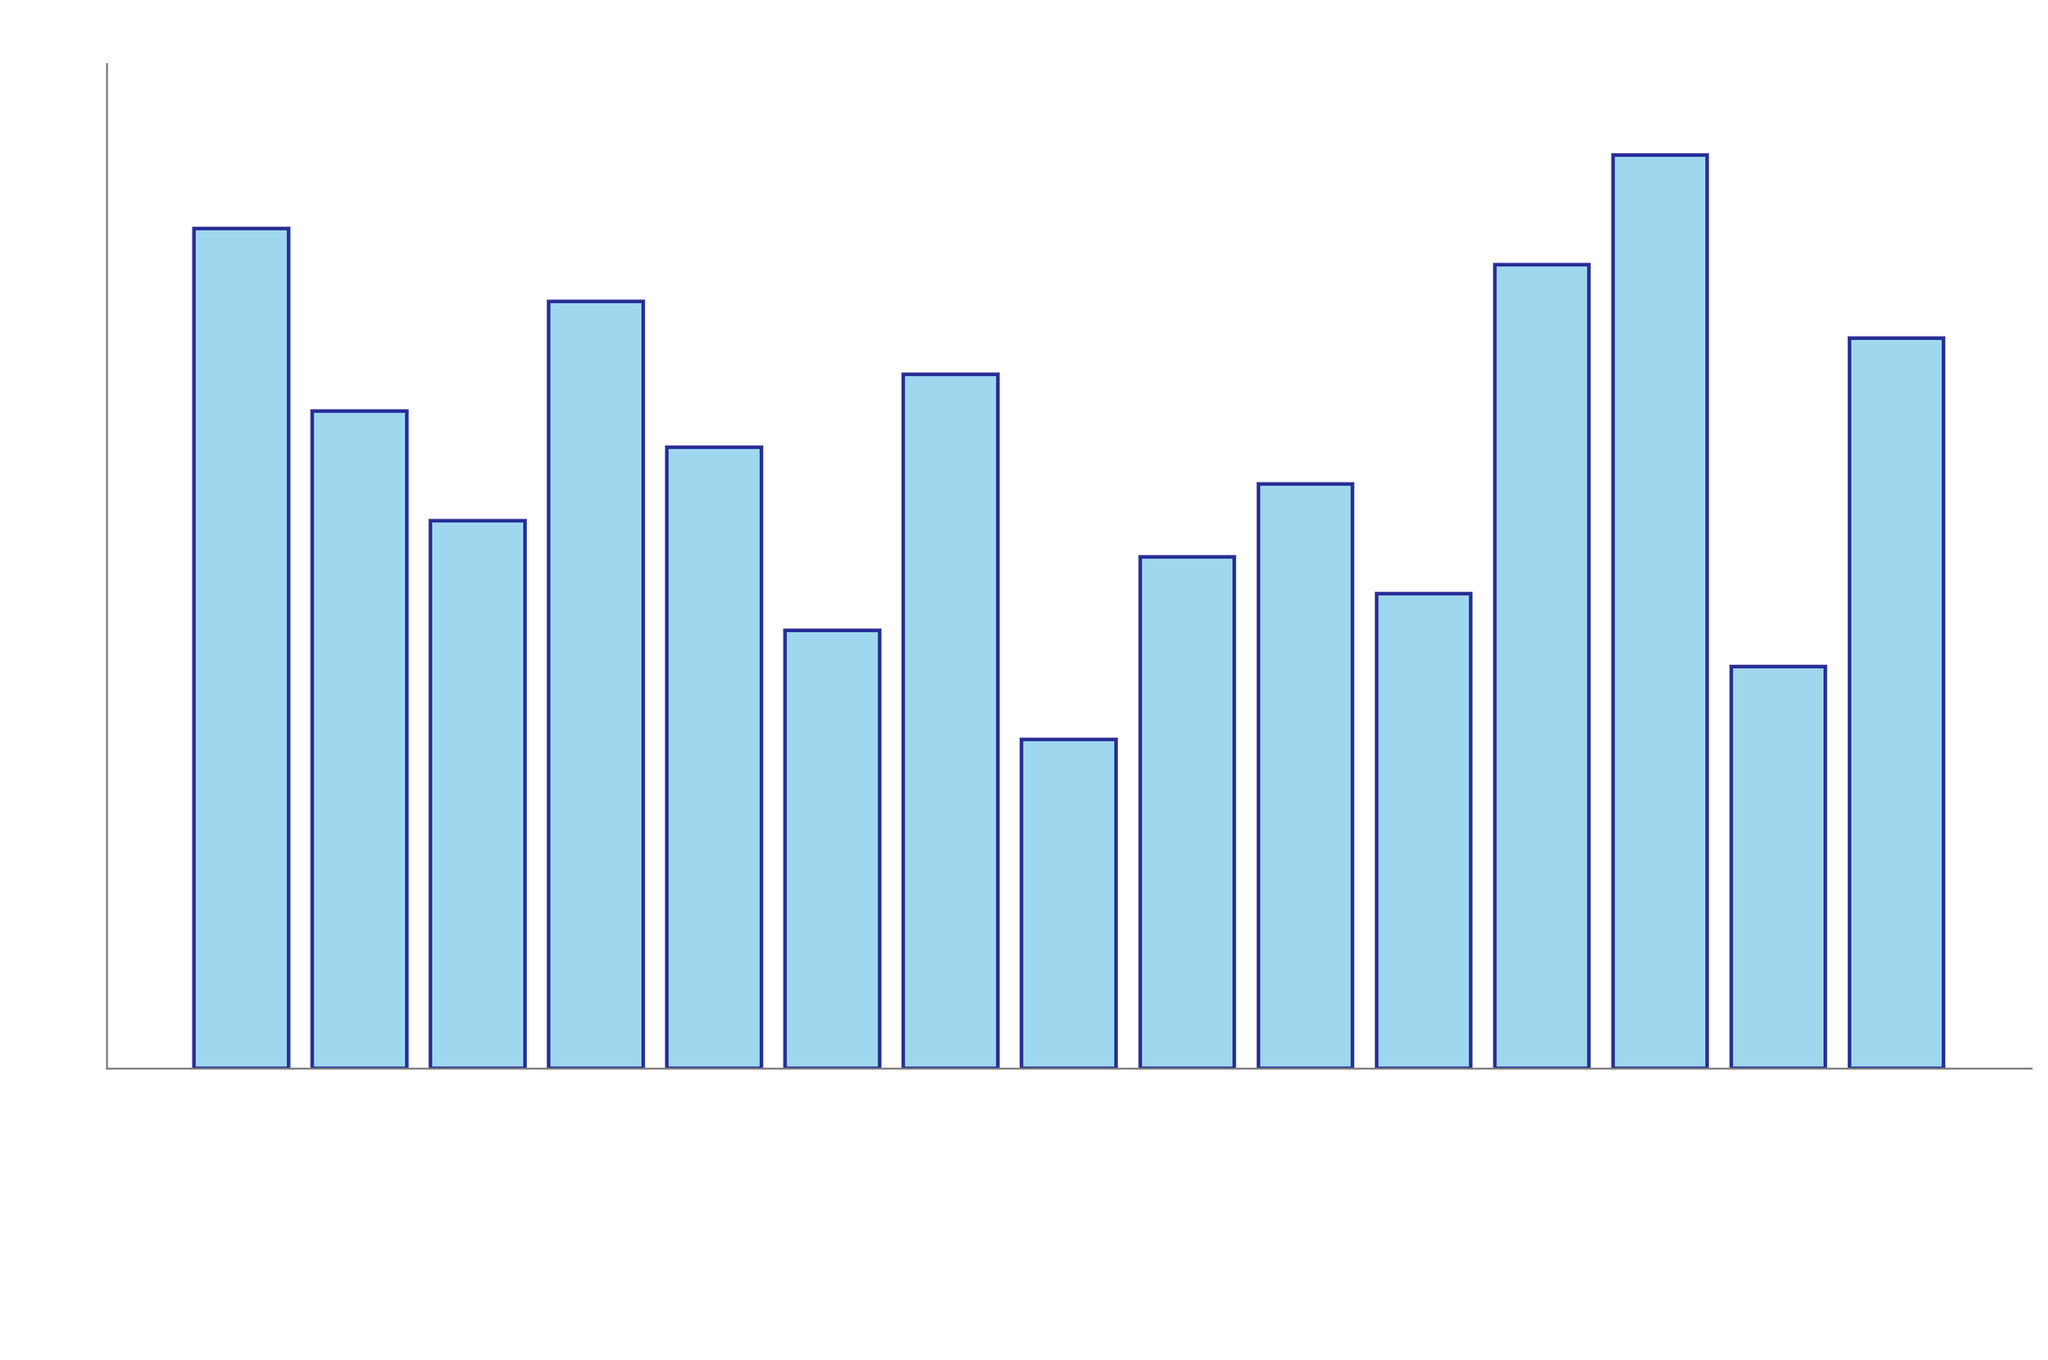Which technique has the highest productivity gain? The bar representing Deep Work Sessions is the tallest, indicating the highest productivity gain percentage.
Answer: Deep Work Sessions Which technique has a productivity gain of 18%? The Time Blocking bar is at the height indicating a productivity gain of 18%.
Answer: Time Blocking How much higher is the productivity gain of Deep Work Sessions compared to Bullet Journaling? Deep Work Sessions has a productivity gain of 25% and Bullet Journaling has a gain of 12%, so the difference is 25% - 12% = 13%.
Answer: 13% Which techniques have a productivity gain higher than 20%? Techniques with productivity gains higher than 20% are those with bars taller than the 20% mark. These are Pomodoro Technique (23%), Kanban Boards (21%), Pareto Principle (80/20 Rule) (22%), and Deep Work Sessions (25%).
Answer: Pomodoro Technique, Kanban Boards, Pareto Principle (80/20 Rule), Deep Work Sessions What is the total productivity gain of Pomodoro Technique, Time Blocking, and Eisenhower Matrix combined? Sum the productivity gains: Pomodoro Technique (23%) + Time Blocking (18%) + Eisenhower Matrix (15%) = 23% + 18% + 15% = 56%.
Answer: 56% Which techniques have an equal productivity gain? Techniques with the same bar heights indicating equal productivity gains are Time Blocking and Getting Things Done (GTD), both at 18%.
Answer: Time Blocking, Getting Things Done (GTD) What is the median productivity gain of all the techniques? List the productivity gains in ascending order: 9%, 11%, 12%, 13%, 14%, 15%, 16%, 17%, 18%, 18%, 19%, 20%, 21%, 22%, 23%, 25%. The median is the middle value, which is the 8th value in the sorted list, i.e., 17%.
Answer: 17% Compare the productivity gains of Eat That Frog and Task Batching. Which is higher? The bar for Task Batching is higher than that for Eat That Frog, indicating a higher productivity gain for Task Batching (20%) compared to Eat That Frog (16%).
Answer: Task Batching What is the visual difference between the bars for the Two-Minute Rule and Pomodoro Technique? The bar for the Pomodoro Technique is visually taller than that for the Two-Minute Rule, indicating a higher productivity gain for the Pomodoro Technique (23%) compared to the Two-Minute Rule (9%).
Answer: Pomodoro Technique is taller What is the average productivity gain of the techniques with more than 15% gain? List the productivity gains: Pomodoro Technique (23%), Time Blocking (18%), Kanban Boards (21%), Getting Things Done (GTD) (17%), Timeboxing (19%), Pareto Principle (80/20 Rule) (22%), Deep Work Sessions (25%), Task Batching (20%), and Eat That Frog (16%). The average is the sum of these values divided by the number of techniques: (23 + 18 + 21 + 17 + 19 + 22 + 25 + 20 + 16) / 9 = 181 / 9 = 20.11%.
Answer: 20.11% 